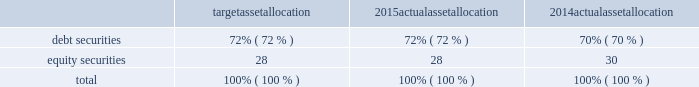Republic services , inc .
Notes to consolidated financial statements 2014 ( continued ) we determine the discount rate used in the measurement of our obligations based on a model that matches the timing and amount of expected benefit payments to maturities of high quality bonds priced as of the plan measurement date .
When that timing does not correspond to a published high-quality bond rate , our model uses an expected yield curve to determine an appropriate current discount rate .
The yields on the bonds are used to derive a discount rate for the liability .
The term of our obligation , based on the expected retirement dates of our workforce , is approximately eight years .
In developing our expected rate of return assumption , we have evaluated the actual historical performance and long-term return projections of the plan assets , which give consideration to the asset mix and the anticipated timing of the plan outflows .
We employ a total return investment approach whereby a mix of equity and fixed income investments are used to maximize the long-term return of plan assets for what we consider a prudent level of risk .
The intent of this strategy is to minimize plan expenses by outperforming plan liabilities over the long run .
Risk tolerance is established through careful consideration of plan liabilities , plan funded status and our financial condition .
The investment portfolio contains a diversified blend of equity and fixed income investments .
Furthermore , equity investments are diversified across u.s .
And non-u.s .
Stocks as well as growth , value , and small and large capitalizations .
Derivatives may be used to gain market exposure in an efficient and timely manner ; however , derivatives may not be used to leverage the portfolio beyond the market value of the underlying investments .
Investment risk is measured and monitored on an ongoing basis through annual liability measurements , periodic asset and liability studies , and quarterly investment portfolio reviews .
The table summarizes our target asset allocation for 2015 and actual asset allocation as of december 31 , 2015 and 2014 for our plan : target allocation actual allocation actual allocation .
For 2016 , the investment strategy for pension plan assets is to maintain a broadly diversified portfolio designed to achieve our target of an average long-term rate of return of 5.64% ( 5.64 % ) .
While we believe we can achieve a long- term average return of 5.64% ( 5.64 % ) , we cannot be certain that the portfolio will perform to our expectations .
Assets are strategically allocated among debt and equity portfolios to achieve a diversification level that reduces fluctuations in investment returns .
Asset allocation target ranges and strategies are reviewed periodically with the assistance of an independent external consulting firm. .
Based on the 2014 actual asset allocation what was the debt to equity ratio? 
Rationale: for every $ 1 of equity the company is funded by $ 2.33 of debt
Computations: (70 / 30)
Answer: 2.33333. 